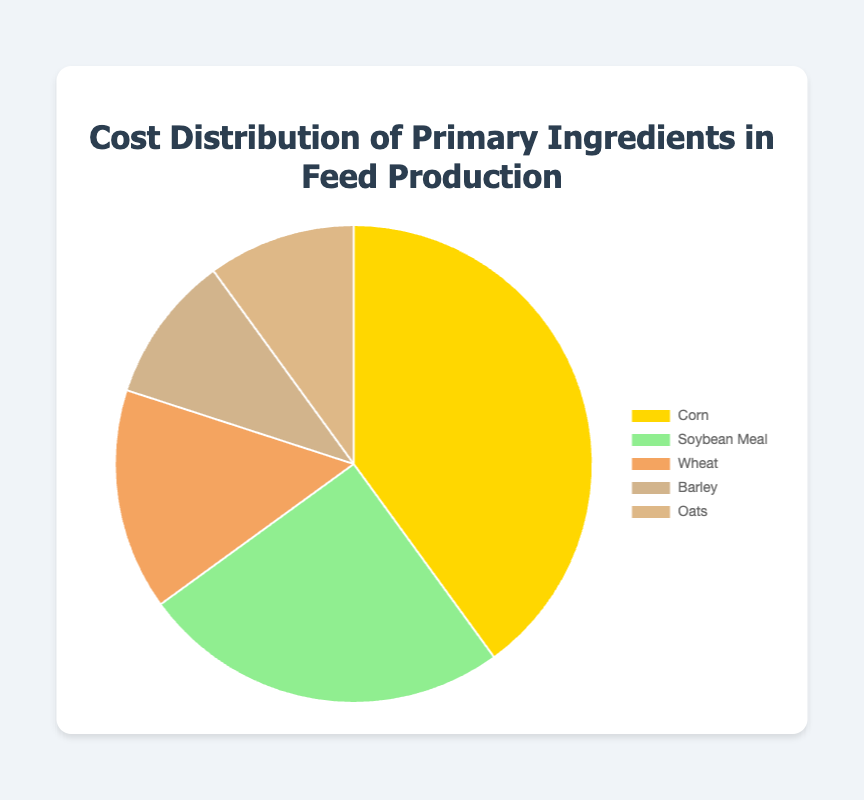What is the most expensive ingredient in terms of cost percentage? The largest segment in the pie chart represents the ingredient with the highest cost percentage. This segment corresponds to Corn.
Answer: Corn Which ingredient has the smallest cost percentage? The smallest segments in the pie chart represent the ingredients with the lowest cost percentage. Both Barley and Oats have the smallest and equal segments.
Answer: Barley and Oats What is the combined cost percentage of Barley and Oats? The segments for Barley and Oats each represent 10%. Adding these gives 10% + 10% = 20%.
Answer: 20% Which is more expensive: Wheat or Soybean Meal? By looking at the size of the segments, the segment for Soybean Meal is larger than Wheat, indicating it has a higher cost percentage.
Answer: Soybean Meal How much more expensive is Corn compared to Wheat? Corn has a cost percentage of 40%, while Wheat has 15%. The difference is 40% - 15% = 25%.
Answer: 25% If you were to combine the cost percentages of Wheat and Soybean Meal, would it surpass the cost percentage of Corn? Wheat is 15% and Soybean Meal is 25%, so combined they are 15% + 25% = 40%, which equals the cost percentage of Corn.
Answer: No What is the second most expensive ingredient? The second largest segment in the pie chart represents Soybean Meal with 25%.
Answer: Soybean Meal List the ingredients in descending order of their cost percentage. From the largest segment to the smallest: Corn (40%), Soybean Meal (25%), Wheat (15%), Barley and Oats (both 10%).
Answer: Corn, Soybean Meal, Wheat, Barley, Oats Which two ingredients have the same cost percentage? Both Barley and Oats have segments that represent 10% each.
Answer: Barley and Oats What percentage of the total cost is attributed to the least expensive ingredient(s)? The least expensive ingredients are Barley and Oats, each with 10%. Therefore, the percentage is 10%.
Answer: 10% 